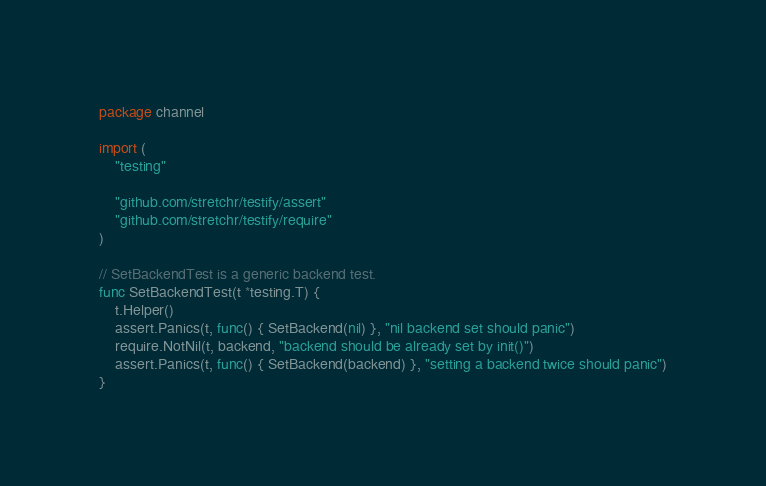<code> <loc_0><loc_0><loc_500><loc_500><_Go_>package channel

import (
	"testing"

	"github.com/stretchr/testify/assert"
	"github.com/stretchr/testify/require"
)

// SetBackendTest is a generic backend test.
func SetBackendTest(t *testing.T) {
	t.Helper()
	assert.Panics(t, func() { SetBackend(nil) }, "nil backend set should panic")
	require.NotNil(t, backend, "backend should be already set by init()")
	assert.Panics(t, func() { SetBackend(backend) }, "setting a backend twice should panic")
}
</code> 